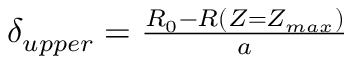<formula> <loc_0><loc_0><loc_500><loc_500>\begin{array} { r } { \delta _ { u p p e r } = \frac { R _ { 0 } - R ( Z = Z _ { \max } ) } { a } } \end{array}</formula> 